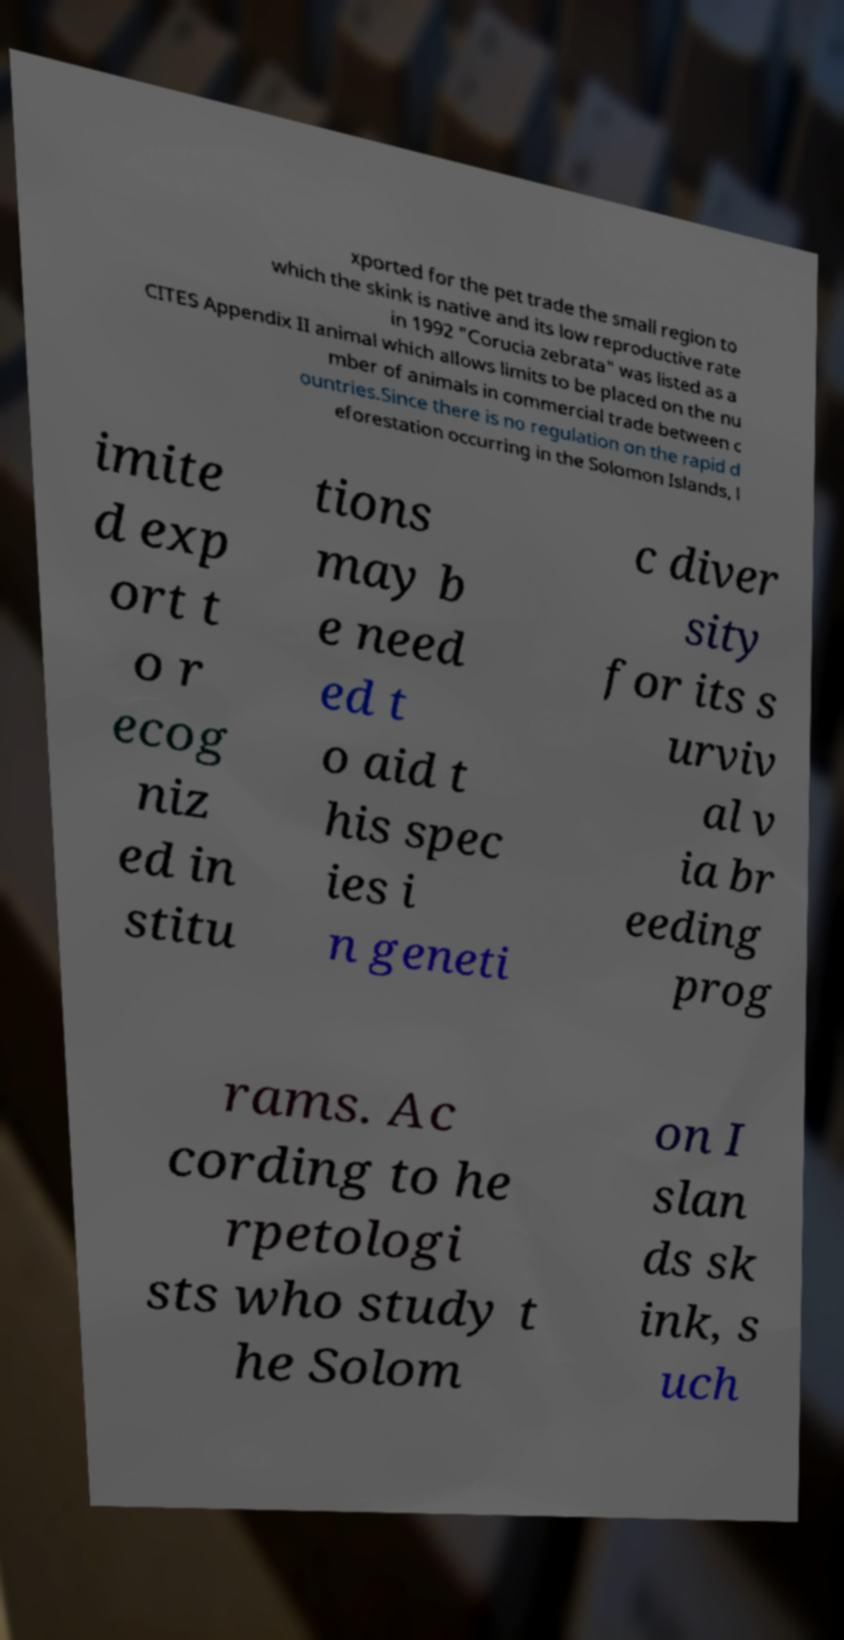Can you accurately transcribe the text from the provided image for me? xported for the pet trade the small region to which the skink is native and its low reproductive rate in 1992 "Corucia zebrata" was listed as a CITES Appendix II animal which allows limits to be placed on the nu mber of animals in commercial trade between c ountries.Since there is no regulation on the rapid d eforestation occurring in the Solomon Islands, l imite d exp ort t o r ecog niz ed in stitu tions may b e need ed t o aid t his spec ies i n geneti c diver sity for its s urviv al v ia br eeding prog rams. Ac cording to he rpetologi sts who study t he Solom on I slan ds sk ink, s uch 